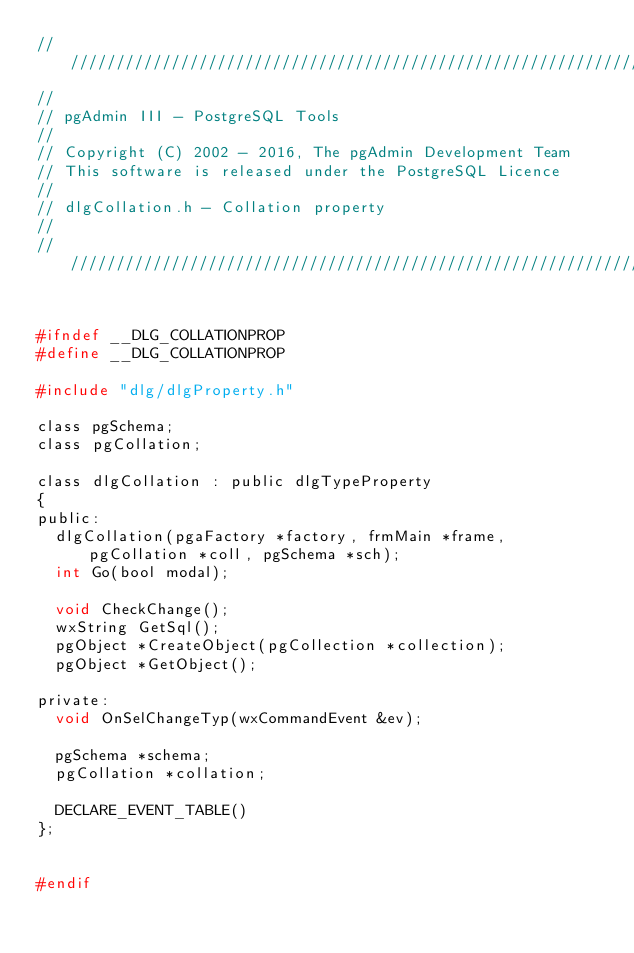<code> <loc_0><loc_0><loc_500><loc_500><_C_>//////////////////////////////////////////////////////////////////////////
//
// pgAdmin III - PostgreSQL Tools
//
// Copyright (C) 2002 - 2016, The pgAdmin Development Team
// This software is released under the PostgreSQL Licence
//
// dlgCollation.h - Collation property
//
//////////////////////////////////////////////////////////////////////////


#ifndef __DLG_COLLATIONPROP
#define __DLG_COLLATIONPROP

#include "dlg/dlgProperty.h"

class pgSchema;
class pgCollation;

class dlgCollation : public dlgTypeProperty
{
public:
	dlgCollation(pgaFactory *factory, frmMain *frame, pgCollation *coll, pgSchema *sch);
	int Go(bool modal);

	void CheckChange();
	wxString GetSql();
	pgObject *CreateObject(pgCollection *collection);
	pgObject *GetObject();

private:
	void OnSelChangeTyp(wxCommandEvent &ev);

	pgSchema *schema;
	pgCollation *collation;

	DECLARE_EVENT_TABLE()
};


#endif
</code> 